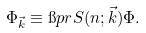<formula> <loc_0><loc_0><loc_500><loc_500>\Phi _ { \vec { k } } \equiv \i p r { S ( n ; \vec { k } ) } { \Phi } .</formula> 